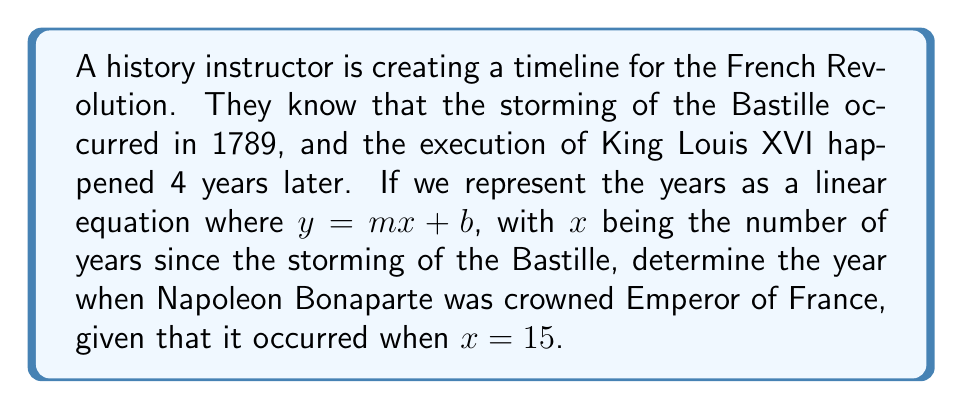Provide a solution to this math problem. Let's approach this step-by-step:

1) We know two points on our timeline:
   - Storming of the Bastille: (0, 1789)
   - Execution of Louis XVI: (4, 1793)

2) We can use these points to find the slope (m) and y-intercept (b) of our linear equation.

3) The slope (m) is:
   $$m = \frac{y_2 - y_1}{x_2 - x_1} = \frac{1793 - 1789}{4 - 0} = \frac{4}{4} = 1$$

4) Now we can use either point to find b. Let's use (0, 1789):
   $$1789 = 1(0) + b$$
   $$b = 1789$$

5) Our linear equation is therefore:
   $$y = 1x + 1789$$

6) To find the year Napoleon was crowned Emperor, we substitute $x = 15$:
   $$y = 1(15) + 1789 = 15 + 1789 = 1804$$

Therefore, Napoleon Bonaparte was crowned Emperor of France in 1804.
Answer: 1804 